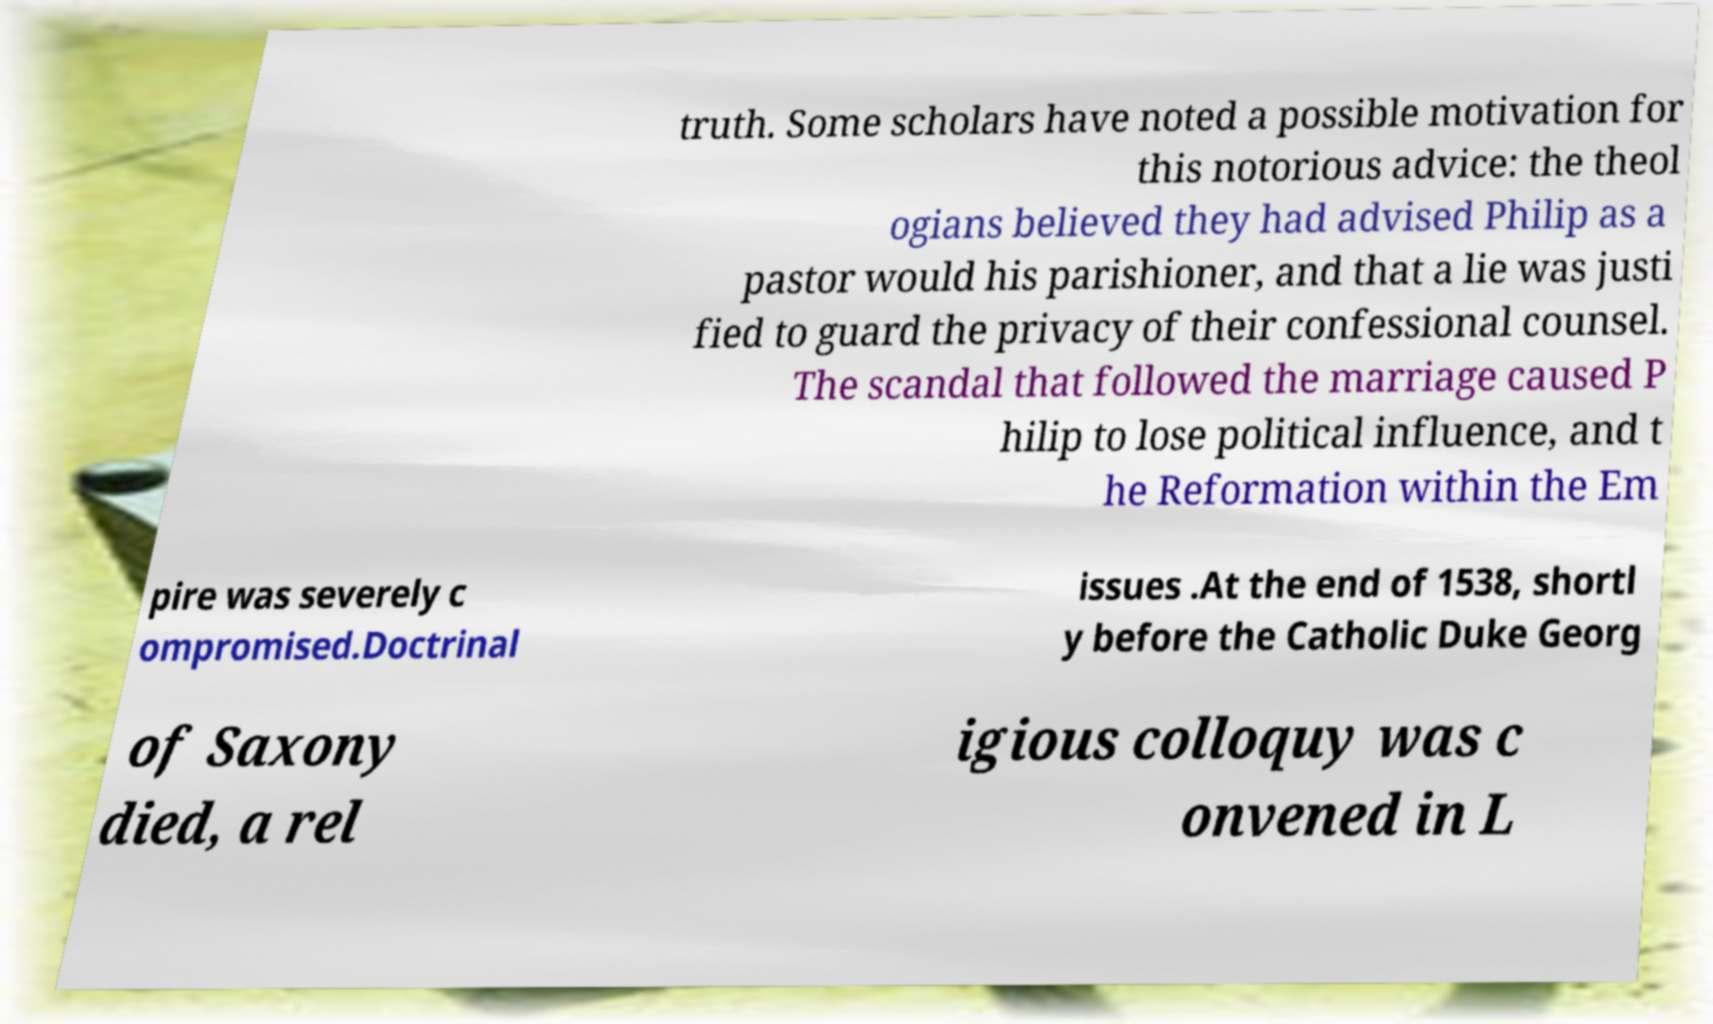Please identify and transcribe the text found in this image. truth. Some scholars have noted a possible motivation for this notorious advice: the theol ogians believed they had advised Philip as a pastor would his parishioner, and that a lie was justi fied to guard the privacy of their confessional counsel. The scandal that followed the marriage caused P hilip to lose political influence, and t he Reformation within the Em pire was severely c ompromised.Doctrinal issues .At the end of 1538, shortl y before the Catholic Duke Georg of Saxony died, a rel igious colloquy was c onvened in L 